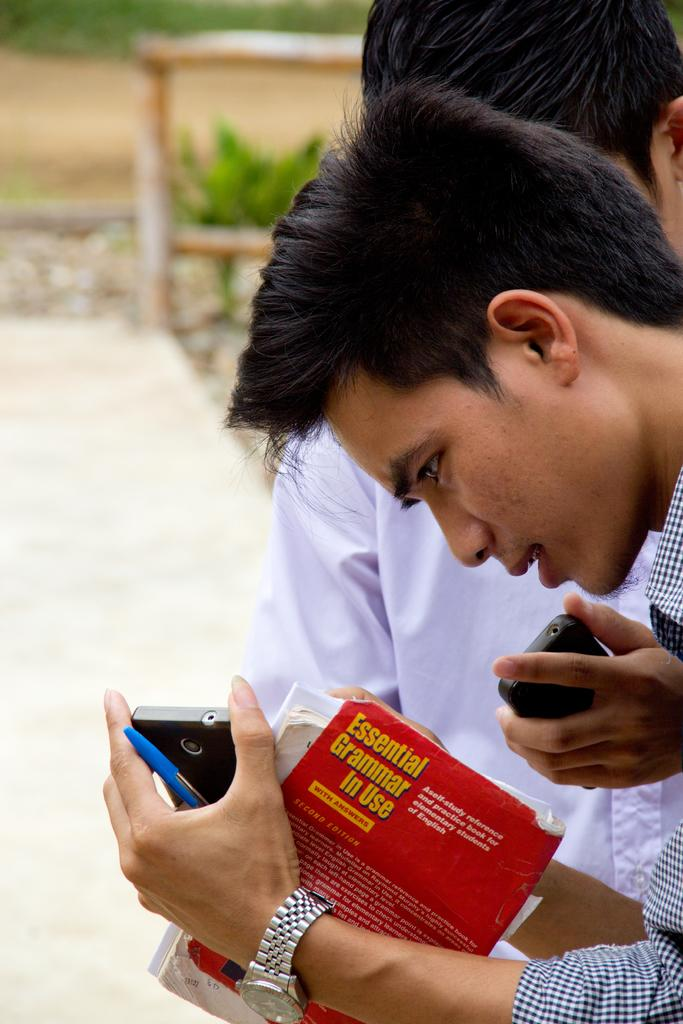How many people are in the image? There are two persons in the image. What are the persons holding in the image? The persons are holding a book. What can be seen in the background of the image? A mobile, a small plant, a wooden pole, and a road can be seen in the background. What type of hydrant is visible in the image? There is no hydrant present in the image. How are the two persons showing respect to each other in the image? The image does not show any indication of the persons showing respect to each other. 